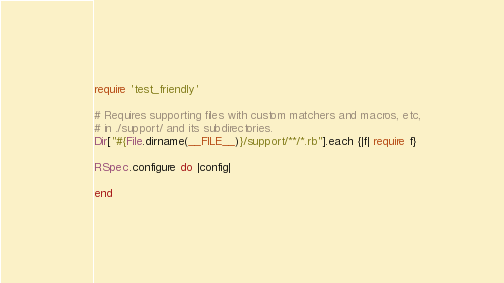<code> <loc_0><loc_0><loc_500><loc_500><_Ruby_>require 'test_friendly'

# Requires supporting files with custom matchers and macros, etc,
# in ./support/ and its subdirectories.
Dir["#{File.dirname(__FILE__)}/support/**/*.rb"].each {|f| require f}

RSpec.configure do |config|
  
end
</code> 